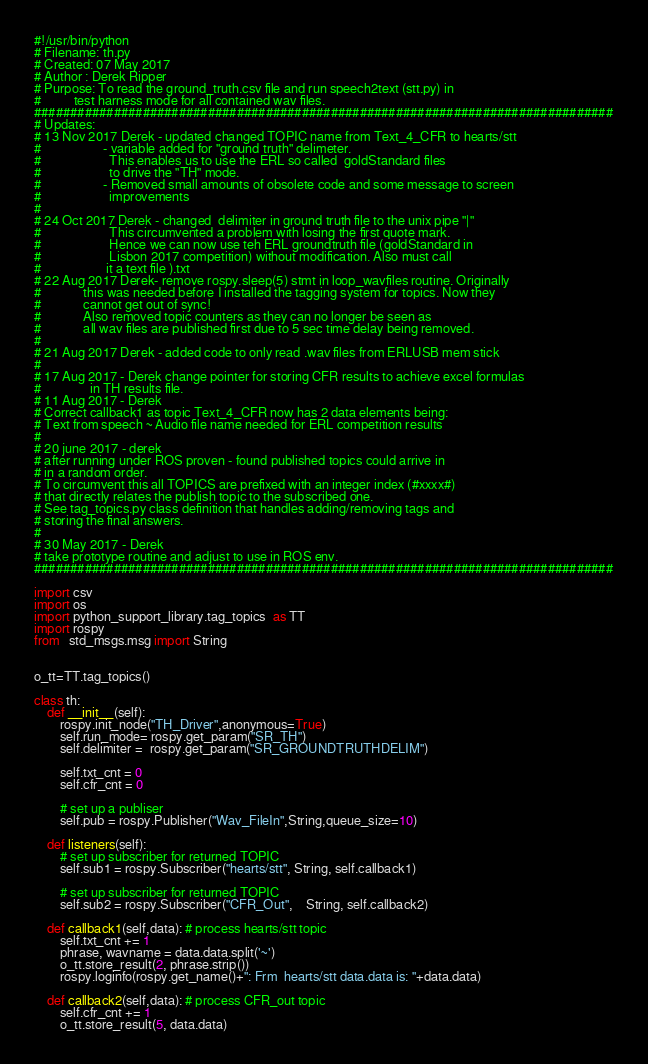<code> <loc_0><loc_0><loc_500><loc_500><_Python_>#!/usr/bin/python
# Filename: th.py
# Created: 07 May 2017
# Author : Derek Ripper
# Purpose: To read the ground_truth.csv file and run speech2text (stt.py) in
#          test harness mode for all contained wav files.
################################################################################
# Updates:
# 13 Nov 2017 Derek - updated changed TOPIC name from Text_4_CFR to hearts/stt
#                   - variable added for "ground truth" delimeter.
#                     This enables us to use the ERL so called  goldStandard files
#                     to drive the "TH" mode.
#                   - Removed small amounts of obsolete code and some message to screen
#                     improvements    
#                     
# 24 Oct 2017 Derek - changed  delimiter in ground truth file to the unix pipe "|"
#                     This circumvented a problem with losing the first quote mark.
#                     Hence we can now use teh ERL groundtruth file (goldStandard in 
#                     Lisbon 2017 competition) without modification. Also must call
#                    it a text file ).txt   
# 22 Aug 2017 Derek- remove rospy.sleep(5) stmt in loop_wavfiles routine. Originally
#             this was needed before I installed the tagging system for topics. Now they 
#             cannot get out of sync! 
#             Also removed topic counters as they can no longer be seen as
#             all wav files are published first due to 5 sec time delay being removed. 
#
# 21 Aug 2017 Derek - added code to only read .wav files from ERLUSB mem stick
#
# 17 Aug 2017 - Derek change pointer for storing CFR results to achieve excel formulas
#               in TH results file. 
# 11 Aug 2017 - Derek
# Correct callback1 as topic Text_4_CFR now has 2 data elements being:
# Text from speech ~ Audio file name needed for ERL competition results
#
# 20 june 2017 - derek
# after running under ROS proven - found published topics could arrive in
# in a random order.
# To circumvent this all TOPICS are prefixed with an integer index (#xxxx#)
# that directly relates the publish topic to the subscribed one. 
# See tag_topics.py class definition that handles adding/removing tags and
# storing the final answers.
#
# 30 May 2017 - Derek
# take prototype routine and adjust to use in ROS env.
################################################################################

import csv
import os
import python_support_library.tag_topics  as TT
import rospy
from   std_msgs.msg import String


o_tt=TT.tag_topics()

class th:
    def __init__(self):    
        rospy.init_node("TH_Driver",anonymous=True)
        self.run_mode= rospy.get_param("SR_TH")
        self.delimiter =  rospy.get_param("SR_GROUNDTRUTHDELIM")
       
        self.txt_cnt = 0
        self.cfr_cnt = 0

        # set up a publiser
        self.pub = rospy.Publisher("Wav_FileIn",String,queue_size=10)

    def listeners(self):
        # set up subscriber for returned TOPIC  
        self.sub1 = rospy.Subscriber("hearts/stt", String, self.callback1)
        
        # set up subscriber for returned TOPIC  
        self.sub2 = rospy.Subscriber("CFR_Out",    String, self.callback2)
    
    def callback1(self,data): # process hearts/stt topic
        self.txt_cnt += 1
        phrase, wavname = data.data.split('~')
        o_tt.store_result(2, phrase.strip())
        rospy.loginfo(rospy.get_name()+": Frm  hearts/stt data.data is: "+data.data) 

    def callback2(self,data): # process CFR_out topic
        self.cfr_cnt += 1
        o_tt.store_result(5, data.data)</code> 